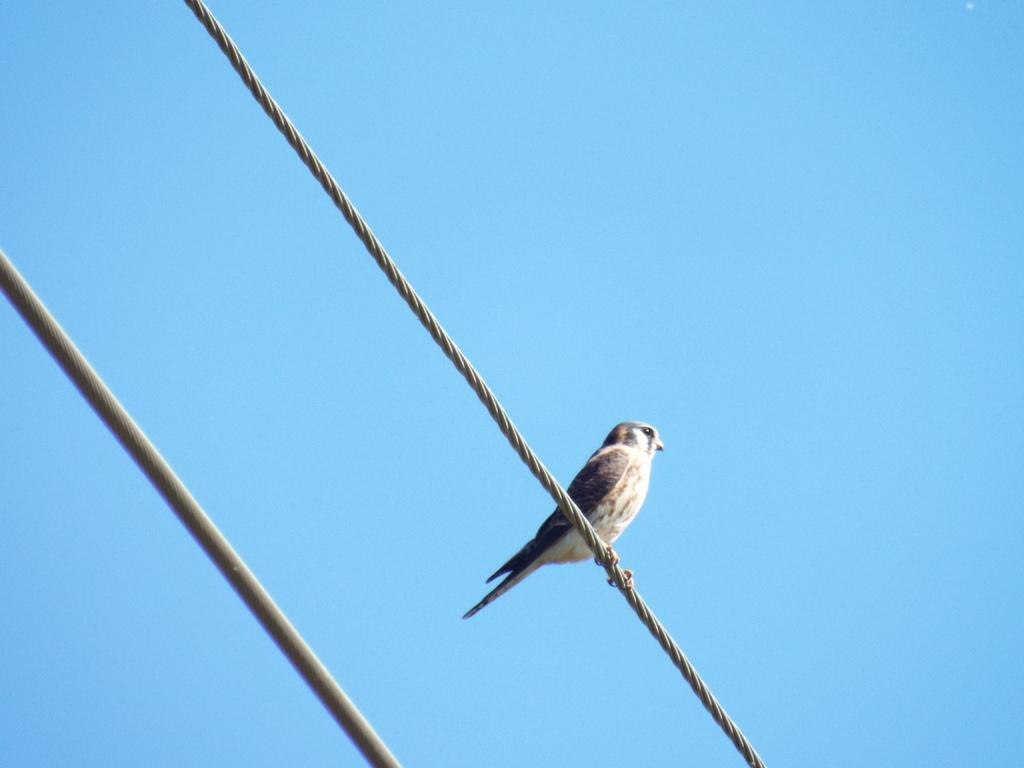What type of animal can be seen in the image? There is a bird in the image. Where is the bird located in the image? The bird is standing on a wire. What else can be seen in the image besides the bird? There are wires in the image. What is visible at the top of the image? The sky is visible at the top of the image. How many tickets are attached to the bird in the image? There are no tickets present in the image, and the bird is not being used for any such purpose. 